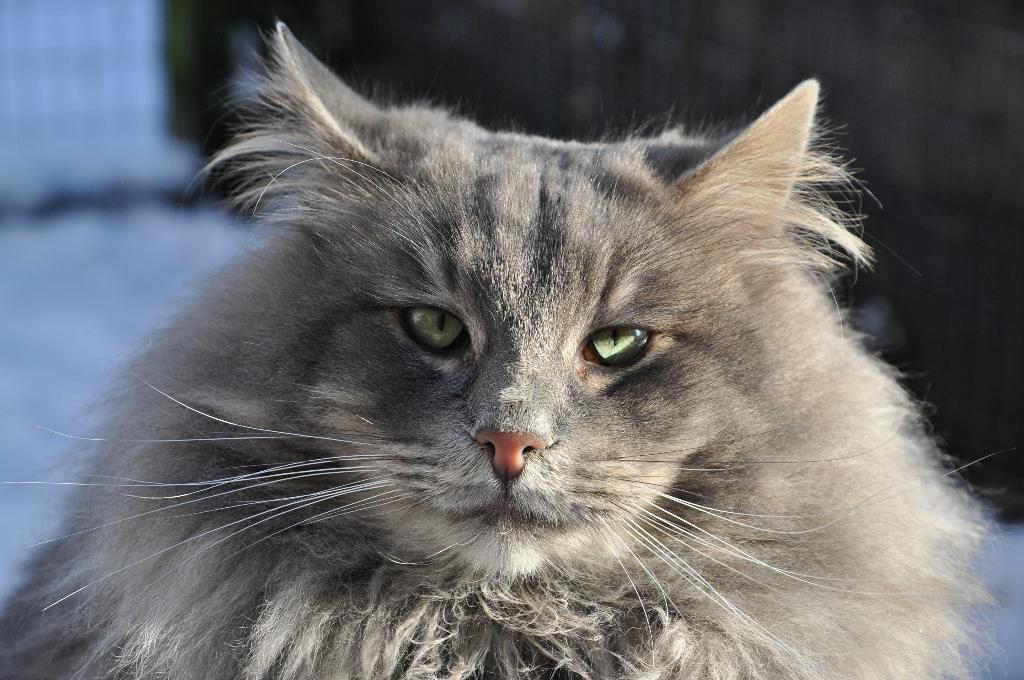What type of animal is present in the image? There is a cat in the image. What type of muscle is visible on the cat's body in the image? There is no specific muscle visible on the cat's body in the image. How does the cat wash itself in the image? The image does not show the cat washing itself, so it cannot be determined from the image. 